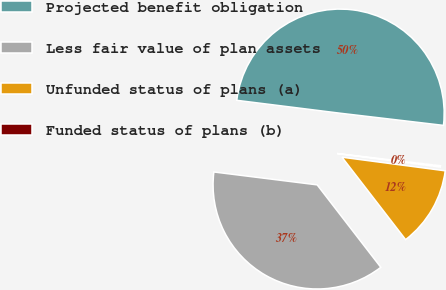<chart> <loc_0><loc_0><loc_500><loc_500><pie_chart><fcel>Projected benefit obligation<fcel>Less fair value of plan assets<fcel>Unfunded status of plans (a)<fcel>Funded status of plans (b)<nl><fcel>49.89%<fcel>37.44%<fcel>12.45%<fcel>0.22%<nl></chart> 